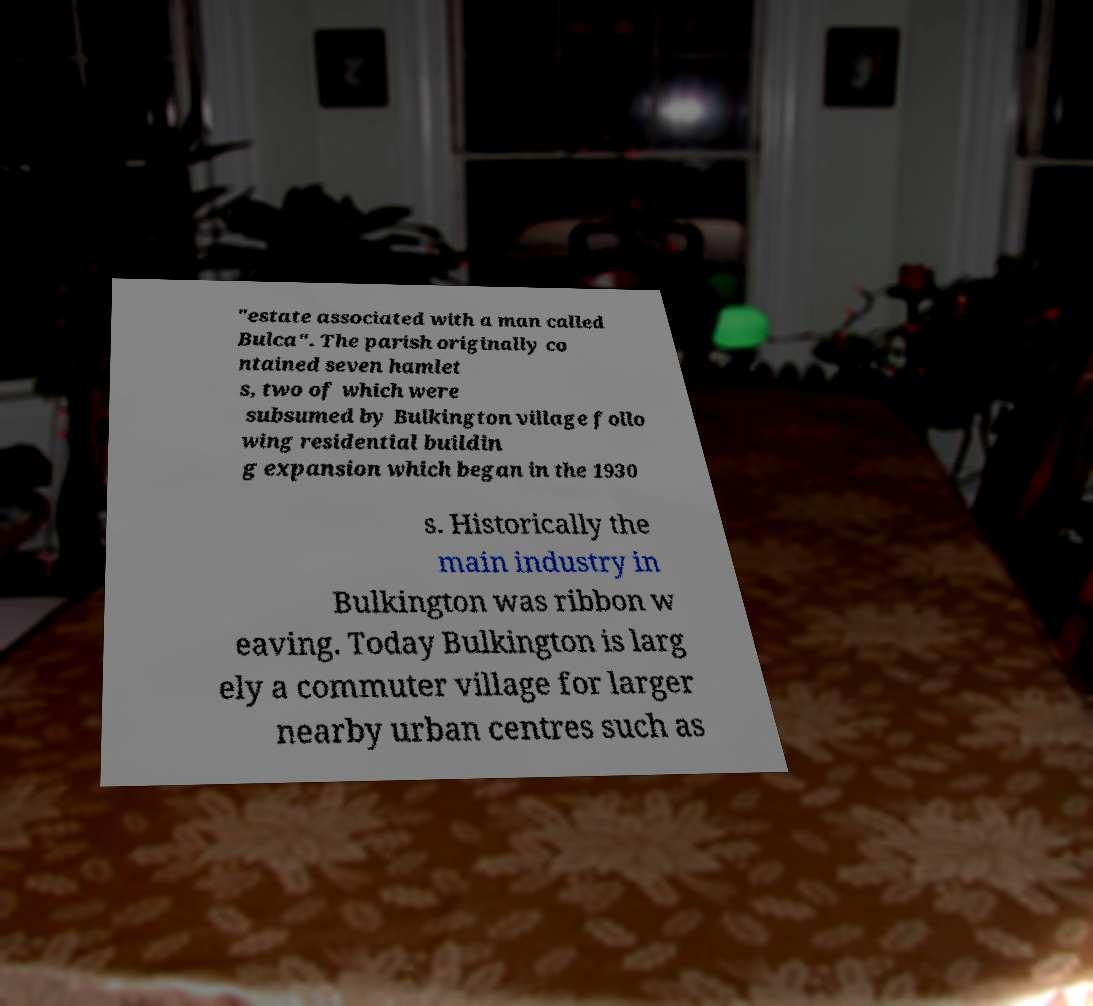For documentation purposes, I need the text within this image transcribed. Could you provide that? "estate associated with a man called Bulca". The parish originally co ntained seven hamlet s, two of which were subsumed by Bulkington village follo wing residential buildin g expansion which began in the 1930 s. Historically the main industry in Bulkington was ribbon w eaving. Today Bulkington is larg ely a commuter village for larger nearby urban centres such as 